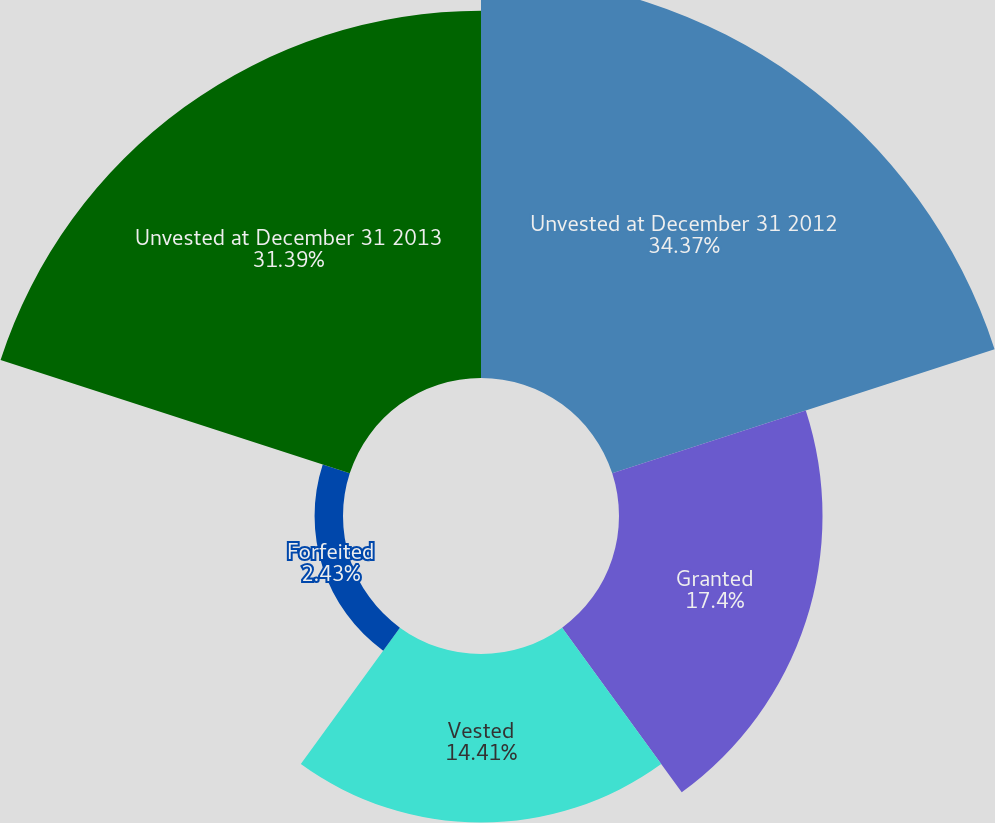Convert chart. <chart><loc_0><loc_0><loc_500><loc_500><pie_chart><fcel>Unvested at December 31 2012<fcel>Granted<fcel>Vested<fcel>Forfeited<fcel>Unvested at December 31 2013<nl><fcel>34.37%<fcel>17.4%<fcel>14.41%<fcel>2.43%<fcel>31.39%<nl></chart> 